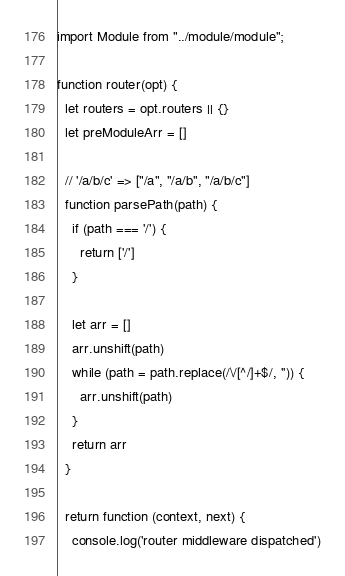<code> <loc_0><loc_0><loc_500><loc_500><_JavaScript_>import Module from "../module/module";

function router(opt) {
  let routers = opt.routers || {}
  let preModuleArr = []

  // '/a/b/c' => ["/a", "/a/b", "/a/b/c"]
  function parsePath(path) {
    if (path === '/') {
      return ['/']
    }

    let arr = []
    arr.unshift(path)
    while (path = path.replace(/\/[^/]+$/, '')) {
      arr.unshift(path)
    }
    return arr
  }

  return function (context, next) {
    console.log('router middleware dispatched')
</code> 